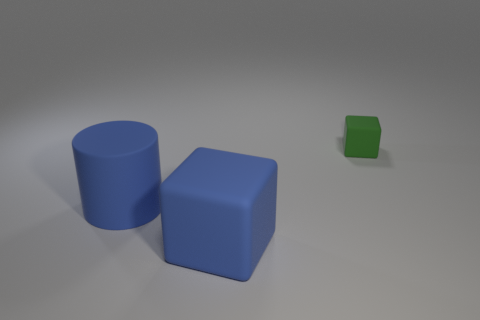What number of big cylinders are the same color as the large rubber cube?
Provide a succinct answer. 1. What color is the large object that is the same shape as the tiny thing?
Offer a terse response. Blue. Are any large matte objects visible?
Your answer should be compact. Yes. There is another rubber object that is the same shape as the tiny green matte thing; what is its size?
Your answer should be very brief. Large. There is a big blue matte object on the left side of the block that is left of the green matte thing; what shape is it?
Make the answer very short. Cylinder. What number of brown objects are either large matte blocks or small things?
Provide a short and direct response. 0. The tiny object is what color?
Your answer should be very brief. Green. Do the green rubber thing and the blue rubber block have the same size?
Provide a short and direct response. No. Is there any other thing that has the same shape as the green matte thing?
Offer a very short reply. Yes. Is the material of the tiny green object the same as the cube in front of the small green matte cube?
Provide a succinct answer. Yes. 